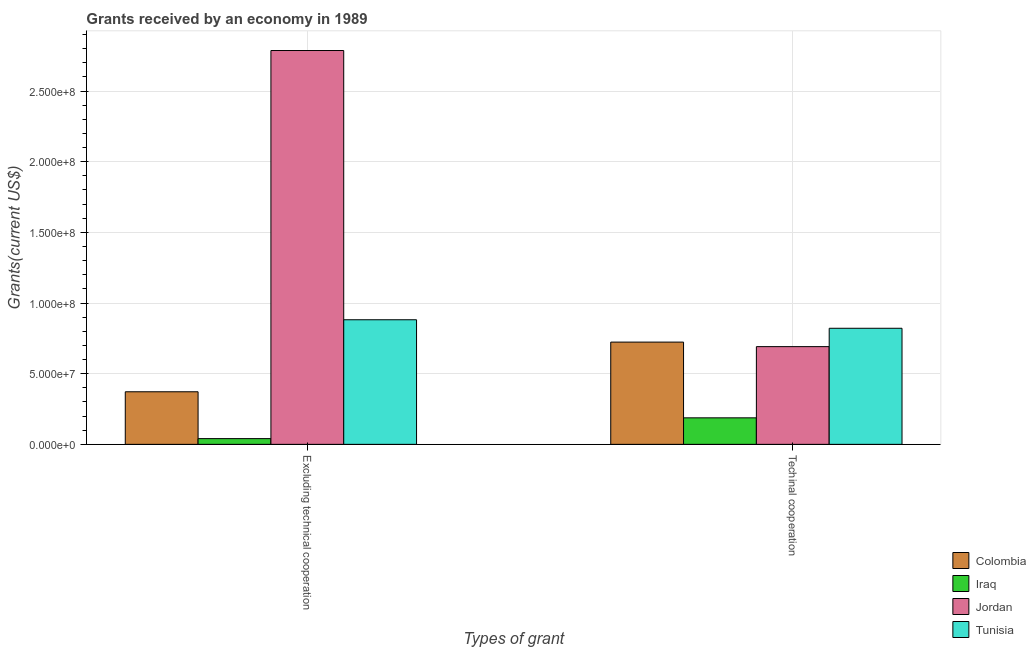How many groups of bars are there?
Your response must be concise. 2. Are the number of bars per tick equal to the number of legend labels?
Make the answer very short. Yes. Are the number of bars on each tick of the X-axis equal?
Offer a terse response. Yes. How many bars are there on the 1st tick from the left?
Provide a short and direct response. 4. How many bars are there on the 2nd tick from the right?
Keep it short and to the point. 4. What is the label of the 1st group of bars from the left?
Keep it short and to the point. Excluding technical cooperation. What is the amount of grants received(including technical cooperation) in Iraq?
Your response must be concise. 1.88e+07. Across all countries, what is the maximum amount of grants received(excluding technical cooperation)?
Offer a very short reply. 2.79e+08. Across all countries, what is the minimum amount of grants received(excluding technical cooperation)?
Make the answer very short. 4.06e+06. In which country was the amount of grants received(including technical cooperation) maximum?
Give a very brief answer. Tunisia. In which country was the amount of grants received(excluding technical cooperation) minimum?
Make the answer very short. Iraq. What is the total amount of grants received(excluding technical cooperation) in the graph?
Your response must be concise. 4.08e+08. What is the difference between the amount of grants received(including technical cooperation) in Colombia and that in Tunisia?
Offer a very short reply. -9.78e+06. What is the difference between the amount of grants received(including technical cooperation) in Jordan and the amount of grants received(excluding technical cooperation) in Colombia?
Give a very brief answer. 3.19e+07. What is the average amount of grants received(including technical cooperation) per country?
Offer a terse response. 6.06e+07. What is the difference between the amount of grants received(excluding technical cooperation) and amount of grants received(including technical cooperation) in Tunisia?
Your answer should be very brief. 6.03e+06. What is the ratio of the amount of grants received(excluding technical cooperation) in Colombia to that in Jordan?
Keep it short and to the point. 0.13. Is the amount of grants received(including technical cooperation) in Iraq less than that in Colombia?
Provide a succinct answer. Yes. What does the 2nd bar from the left in Techinal cooperation represents?
Provide a short and direct response. Iraq. How many bars are there?
Offer a terse response. 8. How many countries are there in the graph?
Ensure brevity in your answer.  4. Does the graph contain any zero values?
Make the answer very short. No. How many legend labels are there?
Keep it short and to the point. 4. How are the legend labels stacked?
Your answer should be very brief. Vertical. What is the title of the graph?
Your answer should be very brief. Grants received by an economy in 1989. What is the label or title of the X-axis?
Ensure brevity in your answer.  Types of grant. What is the label or title of the Y-axis?
Your answer should be compact. Grants(current US$). What is the Grants(current US$) in Colombia in Excluding technical cooperation?
Offer a terse response. 3.72e+07. What is the Grants(current US$) of Iraq in Excluding technical cooperation?
Provide a short and direct response. 4.06e+06. What is the Grants(current US$) of Jordan in Excluding technical cooperation?
Provide a short and direct response. 2.79e+08. What is the Grants(current US$) of Tunisia in Excluding technical cooperation?
Provide a short and direct response. 8.82e+07. What is the Grants(current US$) of Colombia in Techinal cooperation?
Ensure brevity in your answer.  7.24e+07. What is the Grants(current US$) in Iraq in Techinal cooperation?
Your answer should be compact. 1.88e+07. What is the Grants(current US$) in Jordan in Techinal cooperation?
Provide a short and direct response. 6.92e+07. What is the Grants(current US$) of Tunisia in Techinal cooperation?
Your answer should be compact. 8.21e+07. Across all Types of grant, what is the maximum Grants(current US$) in Colombia?
Offer a very short reply. 7.24e+07. Across all Types of grant, what is the maximum Grants(current US$) of Iraq?
Offer a very short reply. 1.88e+07. Across all Types of grant, what is the maximum Grants(current US$) in Jordan?
Offer a very short reply. 2.79e+08. Across all Types of grant, what is the maximum Grants(current US$) in Tunisia?
Your response must be concise. 8.82e+07. Across all Types of grant, what is the minimum Grants(current US$) in Colombia?
Give a very brief answer. 3.72e+07. Across all Types of grant, what is the minimum Grants(current US$) of Iraq?
Make the answer very short. 4.06e+06. Across all Types of grant, what is the minimum Grants(current US$) of Jordan?
Keep it short and to the point. 6.92e+07. Across all Types of grant, what is the minimum Grants(current US$) of Tunisia?
Ensure brevity in your answer.  8.21e+07. What is the total Grants(current US$) of Colombia in the graph?
Ensure brevity in your answer.  1.10e+08. What is the total Grants(current US$) in Iraq in the graph?
Your answer should be compact. 2.28e+07. What is the total Grants(current US$) in Jordan in the graph?
Make the answer very short. 3.48e+08. What is the total Grants(current US$) of Tunisia in the graph?
Keep it short and to the point. 1.70e+08. What is the difference between the Grants(current US$) of Colombia in Excluding technical cooperation and that in Techinal cooperation?
Provide a short and direct response. -3.51e+07. What is the difference between the Grants(current US$) of Iraq in Excluding technical cooperation and that in Techinal cooperation?
Your answer should be very brief. -1.47e+07. What is the difference between the Grants(current US$) of Jordan in Excluding technical cooperation and that in Techinal cooperation?
Keep it short and to the point. 2.10e+08. What is the difference between the Grants(current US$) in Tunisia in Excluding technical cooperation and that in Techinal cooperation?
Offer a very short reply. 6.03e+06. What is the difference between the Grants(current US$) of Colombia in Excluding technical cooperation and the Grants(current US$) of Iraq in Techinal cooperation?
Keep it short and to the point. 1.84e+07. What is the difference between the Grants(current US$) of Colombia in Excluding technical cooperation and the Grants(current US$) of Jordan in Techinal cooperation?
Offer a very short reply. -3.19e+07. What is the difference between the Grants(current US$) of Colombia in Excluding technical cooperation and the Grants(current US$) of Tunisia in Techinal cooperation?
Provide a short and direct response. -4.49e+07. What is the difference between the Grants(current US$) of Iraq in Excluding technical cooperation and the Grants(current US$) of Jordan in Techinal cooperation?
Keep it short and to the point. -6.51e+07. What is the difference between the Grants(current US$) of Iraq in Excluding technical cooperation and the Grants(current US$) of Tunisia in Techinal cooperation?
Offer a very short reply. -7.81e+07. What is the difference between the Grants(current US$) in Jordan in Excluding technical cooperation and the Grants(current US$) in Tunisia in Techinal cooperation?
Your response must be concise. 1.97e+08. What is the average Grants(current US$) of Colombia per Types of grant?
Provide a short and direct response. 5.48e+07. What is the average Grants(current US$) in Iraq per Types of grant?
Make the answer very short. 1.14e+07. What is the average Grants(current US$) of Jordan per Types of grant?
Give a very brief answer. 1.74e+08. What is the average Grants(current US$) of Tunisia per Types of grant?
Provide a short and direct response. 8.51e+07. What is the difference between the Grants(current US$) of Colombia and Grants(current US$) of Iraq in Excluding technical cooperation?
Your answer should be very brief. 3.32e+07. What is the difference between the Grants(current US$) of Colombia and Grants(current US$) of Jordan in Excluding technical cooperation?
Offer a very short reply. -2.41e+08. What is the difference between the Grants(current US$) in Colombia and Grants(current US$) in Tunisia in Excluding technical cooperation?
Provide a short and direct response. -5.10e+07. What is the difference between the Grants(current US$) in Iraq and Grants(current US$) in Jordan in Excluding technical cooperation?
Provide a succinct answer. -2.75e+08. What is the difference between the Grants(current US$) of Iraq and Grants(current US$) of Tunisia in Excluding technical cooperation?
Make the answer very short. -8.41e+07. What is the difference between the Grants(current US$) in Jordan and Grants(current US$) in Tunisia in Excluding technical cooperation?
Offer a terse response. 1.90e+08. What is the difference between the Grants(current US$) of Colombia and Grants(current US$) of Iraq in Techinal cooperation?
Provide a succinct answer. 5.36e+07. What is the difference between the Grants(current US$) of Colombia and Grants(current US$) of Jordan in Techinal cooperation?
Offer a very short reply. 3.20e+06. What is the difference between the Grants(current US$) of Colombia and Grants(current US$) of Tunisia in Techinal cooperation?
Give a very brief answer. -9.78e+06. What is the difference between the Grants(current US$) of Iraq and Grants(current US$) of Jordan in Techinal cooperation?
Give a very brief answer. -5.04e+07. What is the difference between the Grants(current US$) of Iraq and Grants(current US$) of Tunisia in Techinal cooperation?
Your answer should be compact. -6.34e+07. What is the difference between the Grants(current US$) of Jordan and Grants(current US$) of Tunisia in Techinal cooperation?
Offer a terse response. -1.30e+07. What is the ratio of the Grants(current US$) in Colombia in Excluding technical cooperation to that in Techinal cooperation?
Provide a succinct answer. 0.51. What is the ratio of the Grants(current US$) in Iraq in Excluding technical cooperation to that in Techinal cooperation?
Offer a very short reply. 0.22. What is the ratio of the Grants(current US$) in Jordan in Excluding technical cooperation to that in Techinal cooperation?
Keep it short and to the point. 4.03. What is the ratio of the Grants(current US$) in Tunisia in Excluding technical cooperation to that in Techinal cooperation?
Provide a short and direct response. 1.07. What is the difference between the highest and the second highest Grants(current US$) in Colombia?
Keep it short and to the point. 3.51e+07. What is the difference between the highest and the second highest Grants(current US$) of Iraq?
Provide a succinct answer. 1.47e+07. What is the difference between the highest and the second highest Grants(current US$) in Jordan?
Make the answer very short. 2.10e+08. What is the difference between the highest and the second highest Grants(current US$) in Tunisia?
Offer a very short reply. 6.03e+06. What is the difference between the highest and the lowest Grants(current US$) of Colombia?
Keep it short and to the point. 3.51e+07. What is the difference between the highest and the lowest Grants(current US$) of Iraq?
Ensure brevity in your answer.  1.47e+07. What is the difference between the highest and the lowest Grants(current US$) in Jordan?
Your answer should be compact. 2.10e+08. What is the difference between the highest and the lowest Grants(current US$) of Tunisia?
Give a very brief answer. 6.03e+06. 